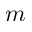Convert formula to latex. <formula><loc_0><loc_0><loc_500><loc_500>m</formula> 